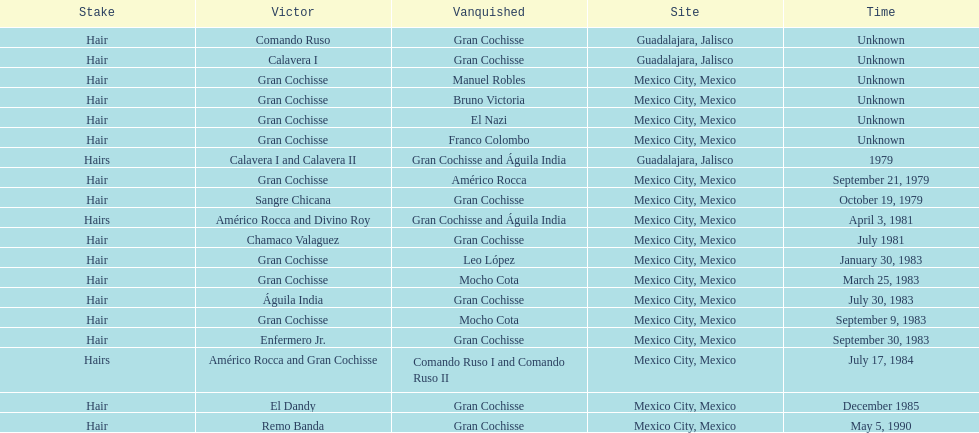How many times has the wager been hair? 16. 